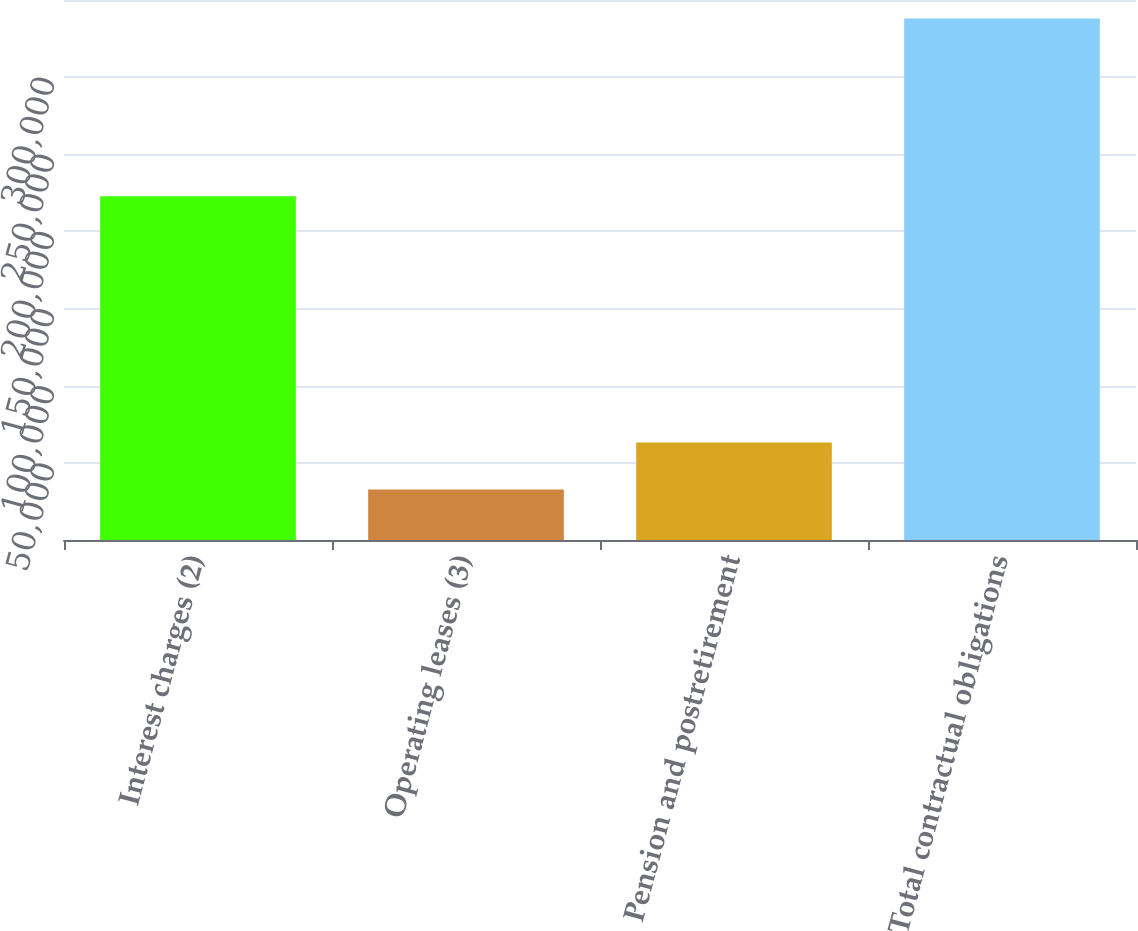<chart> <loc_0><loc_0><loc_500><loc_500><bar_chart><fcel>Interest charges (2)<fcel>Operating leases (3)<fcel>Pension and postretirement<fcel>Total contractual obligations<nl><fcel>222759<fcel>32685<fcel>63222.5<fcel>338060<nl></chart> 